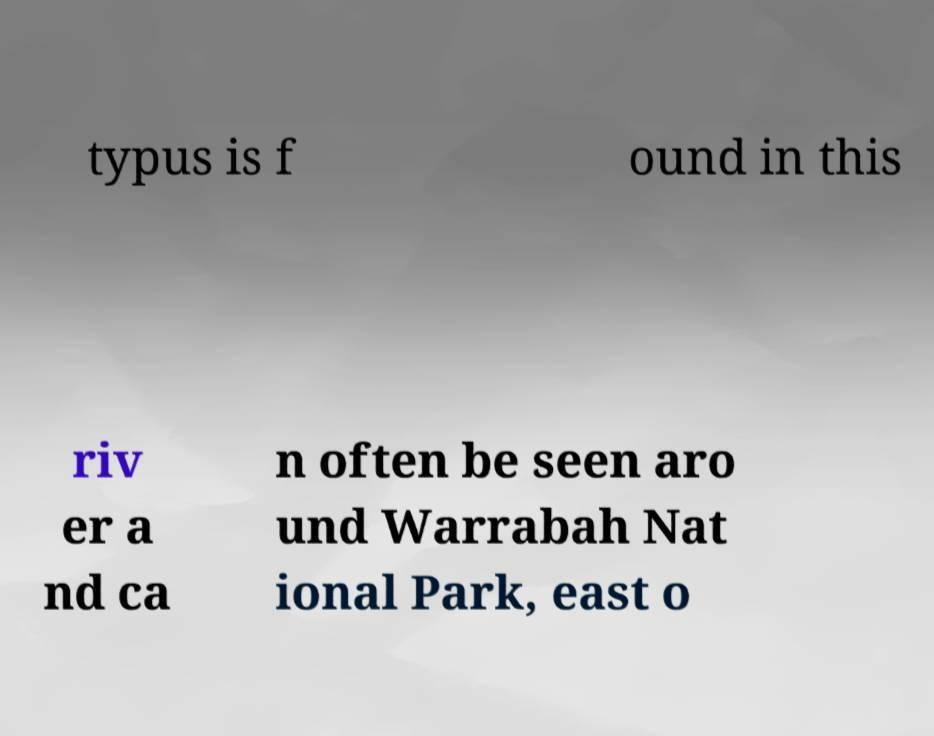There's text embedded in this image that I need extracted. Can you transcribe it verbatim? typus is f ound in this riv er a nd ca n often be seen aro und Warrabah Nat ional Park, east o 